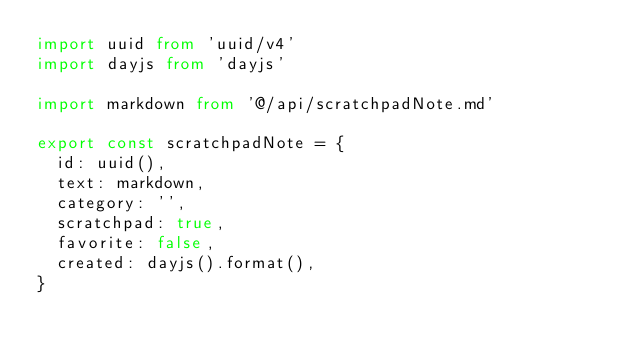Convert code to text. <code><loc_0><loc_0><loc_500><loc_500><_TypeScript_>import uuid from 'uuid/v4'
import dayjs from 'dayjs'

import markdown from '@/api/scratchpadNote.md'

export const scratchpadNote = {
  id: uuid(),
  text: markdown,
  category: '',
  scratchpad: true,
  favorite: false,
  created: dayjs().format(),
}
</code> 